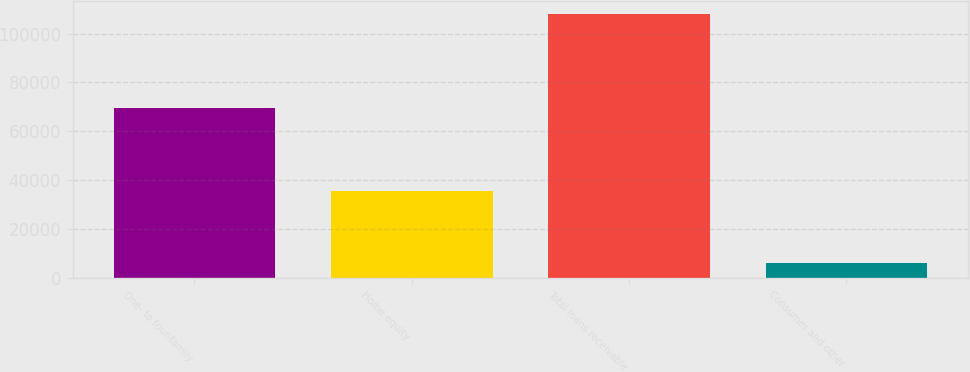Convert chart to OTSL. <chart><loc_0><loc_0><loc_500><loc_500><bar_chart><fcel>One- to four-family<fcel>Home equity<fcel>Total loans receivable<fcel>Consumer and other<nl><fcel>69522<fcel>35721<fcel>108084<fcel>6178<nl></chart> 